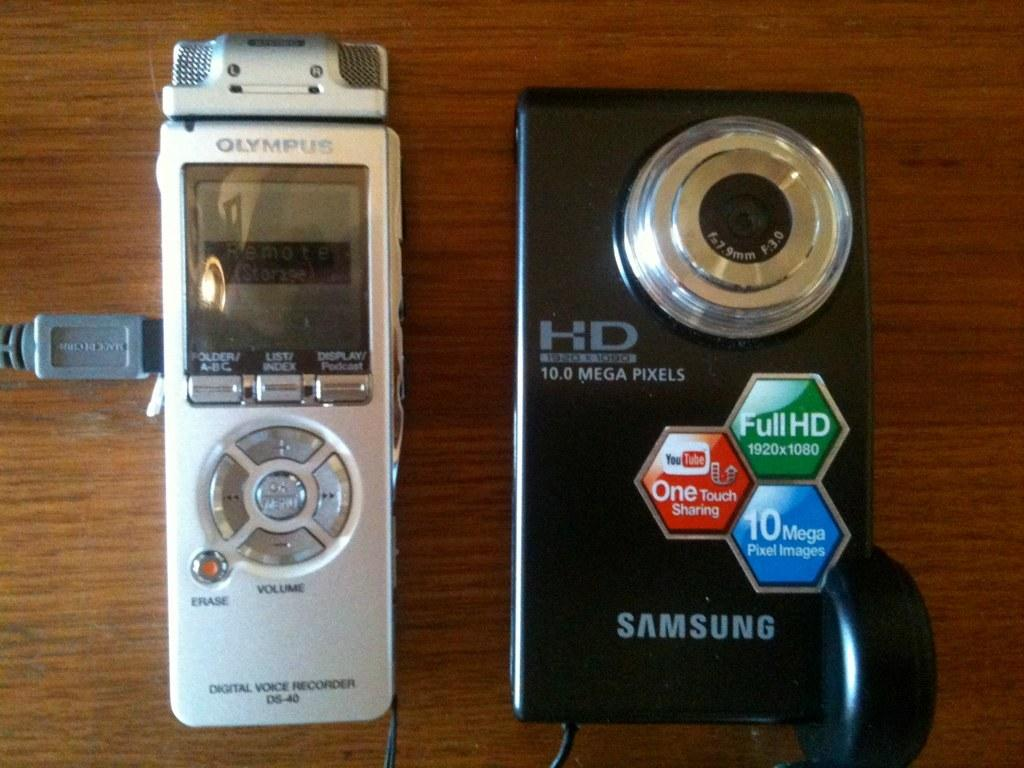<image>
Offer a succinct explanation of the picture presented. A silver Olympus digital voice recorder sitting next to a black Samsung HD camera on a table. 